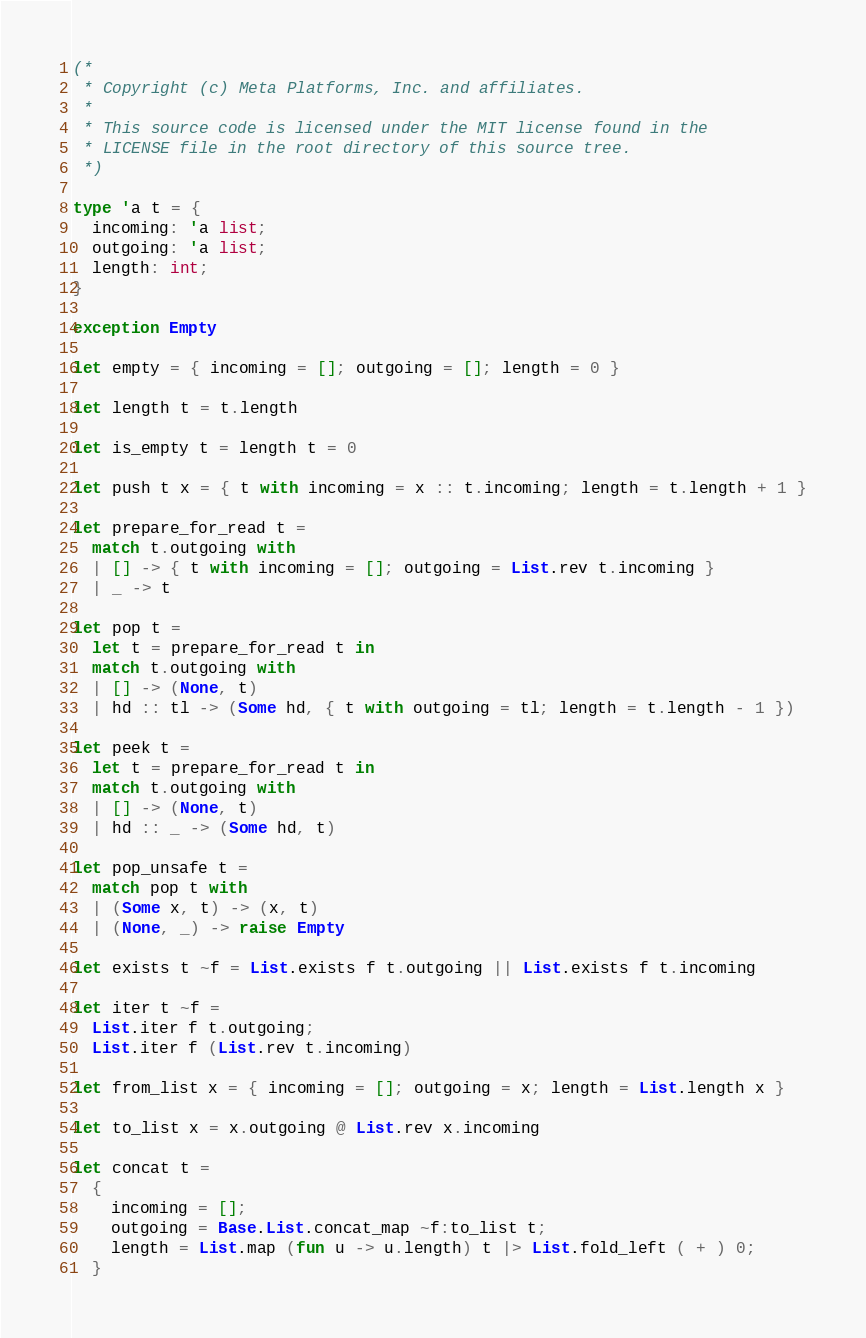<code> <loc_0><loc_0><loc_500><loc_500><_OCaml_>(*
 * Copyright (c) Meta Platforms, Inc. and affiliates.
 *
 * This source code is licensed under the MIT license found in the
 * LICENSE file in the root directory of this source tree.
 *)

type 'a t = {
  incoming: 'a list;
  outgoing: 'a list;
  length: int;
}

exception Empty

let empty = { incoming = []; outgoing = []; length = 0 }

let length t = t.length

let is_empty t = length t = 0

let push t x = { t with incoming = x :: t.incoming; length = t.length + 1 }

let prepare_for_read t =
  match t.outgoing with
  | [] -> { t with incoming = []; outgoing = List.rev t.incoming }
  | _ -> t

let pop t =
  let t = prepare_for_read t in
  match t.outgoing with
  | [] -> (None, t)
  | hd :: tl -> (Some hd, { t with outgoing = tl; length = t.length - 1 })

let peek t =
  let t = prepare_for_read t in
  match t.outgoing with
  | [] -> (None, t)
  | hd :: _ -> (Some hd, t)

let pop_unsafe t =
  match pop t with
  | (Some x, t) -> (x, t)
  | (None, _) -> raise Empty

let exists t ~f = List.exists f t.outgoing || List.exists f t.incoming

let iter t ~f =
  List.iter f t.outgoing;
  List.iter f (List.rev t.incoming)

let from_list x = { incoming = []; outgoing = x; length = List.length x }

let to_list x = x.outgoing @ List.rev x.incoming

let concat t =
  {
    incoming = [];
    outgoing = Base.List.concat_map ~f:to_list t;
    length = List.map (fun u -> u.length) t |> List.fold_left ( + ) 0;
  }
</code> 